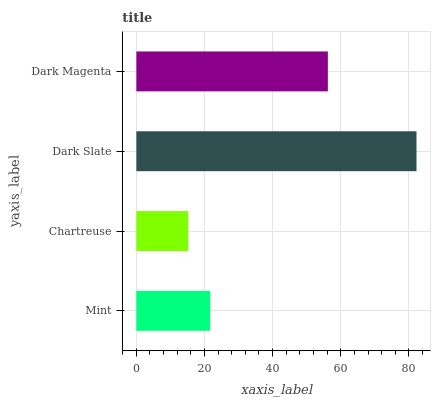Is Chartreuse the minimum?
Answer yes or no. Yes. Is Dark Slate the maximum?
Answer yes or no. Yes. Is Dark Slate the minimum?
Answer yes or no. No. Is Chartreuse the maximum?
Answer yes or no. No. Is Dark Slate greater than Chartreuse?
Answer yes or no. Yes. Is Chartreuse less than Dark Slate?
Answer yes or no. Yes. Is Chartreuse greater than Dark Slate?
Answer yes or no. No. Is Dark Slate less than Chartreuse?
Answer yes or no. No. Is Dark Magenta the high median?
Answer yes or no. Yes. Is Mint the low median?
Answer yes or no. Yes. Is Chartreuse the high median?
Answer yes or no. No. Is Dark Magenta the low median?
Answer yes or no. No. 